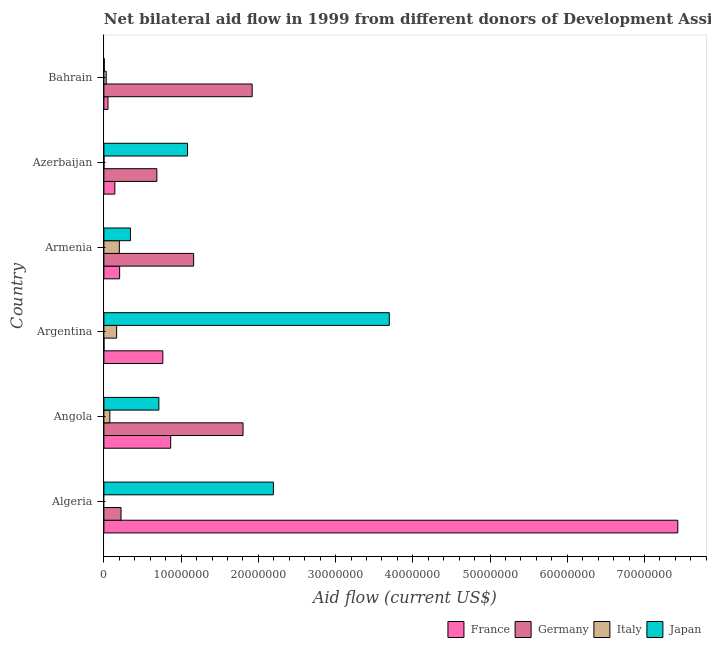How many different coloured bars are there?
Keep it short and to the point. 4. How many groups of bars are there?
Keep it short and to the point. 6. Are the number of bars per tick equal to the number of legend labels?
Offer a very short reply. No. Are the number of bars on each tick of the Y-axis equal?
Ensure brevity in your answer.  No. What is the label of the 2nd group of bars from the top?
Your response must be concise. Azerbaijan. Across all countries, what is the maximum amount of aid given by japan?
Give a very brief answer. 3.70e+07. Across all countries, what is the minimum amount of aid given by japan?
Your response must be concise. 5.00e+04. In which country was the amount of aid given by france maximum?
Your answer should be very brief. Algeria. What is the total amount of aid given by italy in the graph?
Ensure brevity in your answer.  4.73e+06. What is the difference between the amount of aid given by france in Argentina and that in Azerbaijan?
Your answer should be very brief. 6.21e+06. What is the difference between the amount of aid given by italy in Angola and the amount of aid given by germany in Armenia?
Your response must be concise. -1.08e+07. What is the average amount of aid given by germany per country?
Provide a succinct answer. 9.66e+06. What is the difference between the amount of aid given by italy and amount of aid given by japan in Angola?
Offer a very short reply. -6.35e+06. What is the ratio of the amount of aid given by italy in Armenia to that in Bahrain?
Offer a terse response. 6.67. Is the amount of aid given by japan in Algeria less than that in Bahrain?
Your answer should be very brief. No. What is the difference between the highest and the lowest amount of aid given by japan?
Offer a very short reply. 3.69e+07. Is it the case that in every country, the sum of the amount of aid given by italy and amount of aid given by japan is greater than the sum of amount of aid given by germany and amount of aid given by france?
Ensure brevity in your answer.  No. Are all the bars in the graph horizontal?
Offer a very short reply. Yes. How many countries are there in the graph?
Ensure brevity in your answer.  6. Are the values on the major ticks of X-axis written in scientific E-notation?
Your response must be concise. No. Does the graph contain any zero values?
Your response must be concise. Yes. Does the graph contain grids?
Your response must be concise. No. How many legend labels are there?
Keep it short and to the point. 4. What is the title of the graph?
Make the answer very short. Net bilateral aid flow in 1999 from different donors of Development Assistance Committee. Does "Finland" appear as one of the legend labels in the graph?
Your response must be concise. No. What is the Aid flow (current US$) of France in Algeria?
Give a very brief answer. 7.43e+07. What is the Aid flow (current US$) of Germany in Algeria?
Your answer should be very brief. 2.22e+06. What is the Aid flow (current US$) in Italy in Algeria?
Provide a short and direct response. 0. What is the Aid flow (current US$) of Japan in Algeria?
Your answer should be compact. 2.20e+07. What is the Aid flow (current US$) of France in Angola?
Keep it short and to the point. 8.65e+06. What is the Aid flow (current US$) of Germany in Angola?
Provide a succinct answer. 1.80e+07. What is the Aid flow (current US$) of Italy in Angola?
Provide a short and direct response. 7.70e+05. What is the Aid flow (current US$) in Japan in Angola?
Offer a terse response. 7.12e+06. What is the Aid flow (current US$) of France in Argentina?
Offer a terse response. 7.63e+06. What is the Aid flow (current US$) of Germany in Argentina?
Your response must be concise. 10000. What is the Aid flow (current US$) of Italy in Argentina?
Ensure brevity in your answer.  1.65e+06. What is the Aid flow (current US$) in Japan in Argentina?
Make the answer very short. 3.70e+07. What is the Aid flow (current US$) in France in Armenia?
Your answer should be very brief. 2.04e+06. What is the Aid flow (current US$) in Germany in Armenia?
Your response must be concise. 1.16e+07. What is the Aid flow (current US$) in Italy in Armenia?
Keep it short and to the point. 2.00e+06. What is the Aid flow (current US$) of Japan in Armenia?
Give a very brief answer. 3.44e+06. What is the Aid flow (current US$) in France in Azerbaijan?
Provide a short and direct response. 1.42e+06. What is the Aid flow (current US$) of Germany in Azerbaijan?
Make the answer very short. 6.86e+06. What is the Aid flow (current US$) in Italy in Azerbaijan?
Ensure brevity in your answer.  10000. What is the Aid flow (current US$) of Japan in Azerbaijan?
Give a very brief answer. 1.08e+07. What is the Aid flow (current US$) in France in Bahrain?
Keep it short and to the point. 5.30e+05. What is the Aid flow (current US$) in Germany in Bahrain?
Offer a very short reply. 1.92e+07. What is the Aid flow (current US$) of Italy in Bahrain?
Your response must be concise. 3.00e+05. Across all countries, what is the maximum Aid flow (current US$) in France?
Provide a succinct answer. 7.43e+07. Across all countries, what is the maximum Aid flow (current US$) of Germany?
Offer a terse response. 1.92e+07. Across all countries, what is the maximum Aid flow (current US$) in Japan?
Your answer should be compact. 3.70e+07. Across all countries, what is the minimum Aid flow (current US$) of France?
Keep it short and to the point. 5.30e+05. Across all countries, what is the minimum Aid flow (current US$) of Germany?
Your answer should be very brief. 10000. Across all countries, what is the minimum Aid flow (current US$) of Italy?
Provide a short and direct response. 0. Across all countries, what is the minimum Aid flow (current US$) of Japan?
Ensure brevity in your answer.  5.00e+04. What is the total Aid flow (current US$) of France in the graph?
Make the answer very short. 9.46e+07. What is the total Aid flow (current US$) in Germany in the graph?
Ensure brevity in your answer.  5.79e+07. What is the total Aid flow (current US$) of Italy in the graph?
Provide a short and direct response. 4.73e+06. What is the total Aid flow (current US$) in Japan in the graph?
Your answer should be very brief. 8.04e+07. What is the difference between the Aid flow (current US$) in France in Algeria and that in Angola?
Offer a terse response. 6.57e+07. What is the difference between the Aid flow (current US$) in Germany in Algeria and that in Angola?
Offer a terse response. -1.58e+07. What is the difference between the Aid flow (current US$) in Japan in Algeria and that in Angola?
Make the answer very short. 1.48e+07. What is the difference between the Aid flow (current US$) in France in Algeria and that in Argentina?
Give a very brief answer. 6.67e+07. What is the difference between the Aid flow (current US$) in Germany in Algeria and that in Argentina?
Offer a terse response. 2.21e+06. What is the difference between the Aid flow (current US$) of Japan in Algeria and that in Argentina?
Give a very brief answer. -1.50e+07. What is the difference between the Aid flow (current US$) of France in Algeria and that in Armenia?
Give a very brief answer. 7.23e+07. What is the difference between the Aid flow (current US$) of Germany in Algeria and that in Armenia?
Offer a very short reply. -9.40e+06. What is the difference between the Aid flow (current US$) of Japan in Algeria and that in Armenia?
Provide a short and direct response. 1.85e+07. What is the difference between the Aid flow (current US$) of France in Algeria and that in Azerbaijan?
Ensure brevity in your answer.  7.29e+07. What is the difference between the Aid flow (current US$) of Germany in Algeria and that in Azerbaijan?
Ensure brevity in your answer.  -4.64e+06. What is the difference between the Aid flow (current US$) in Japan in Algeria and that in Azerbaijan?
Make the answer very short. 1.11e+07. What is the difference between the Aid flow (current US$) in France in Algeria and that in Bahrain?
Provide a succinct answer. 7.38e+07. What is the difference between the Aid flow (current US$) in Germany in Algeria and that in Bahrain?
Provide a succinct answer. -1.70e+07. What is the difference between the Aid flow (current US$) of Japan in Algeria and that in Bahrain?
Offer a terse response. 2.19e+07. What is the difference between the Aid flow (current US$) of France in Angola and that in Argentina?
Your response must be concise. 1.02e+06. What is the difference between the Aid flow (current US$) of Germany in Angola and that in Argentina?
Your answer should be very brief. 1.80e+07. What is the difference between the Aid flow (current US$) in Italy in Angola and that in Argentina?
Offer a terse response. -8.80e+05. What is the difference between the Aid flow (current US$) in Japan in Angola and that in Argentina?
Provide a short and direct response. -2.98e+07. What is the difference between the Aid flow (current US$) of France in Angola and that in Armenia?
Your answer should be compact. 6.61e+06. What is the difference between the Aid flow (current US$) in Germany in Angola and that in Armenia?
Your response must be concise. 6.40e+06. What is the difference between the Aid flow (current US$) of Italy in Angola and that in Armenia?
Make the answer very short. -1.23e+06. What is the difference between the Aid flow (current US$) in Japan in Angola and that in Armenia?
Ensure brevity in your answer.  3.68e+06. What is the difference between the Aid flow (current US$) in France in Angola and that in Azerbaijan?
Offer a very short reply. 7.23e+06. What is the difference between the Aid flow (current US$) of Germany in Angola and that in Azerbaijan?
Your response must be concise. 1.12e+07. What is the difference between the Aid flow (current US$) of Italy in Angola and that in Azerbaijan?
Ensure brevity in your answer.  7.60e+05. What is the difference between the Aid flow (current US$) of Japan in Angola and that in Azerbaijan?
Offer a very short reply. -3.71e+06. What is the difference between the Aid flow (current US$) in France in Angola and that in Bahrain?
Offer a very short reply. 8.12e+06. What is the difference between the Aid flow (current US$) of Germany in Angola and that in Bahrain?
Offer a very short reply. -1.18e+06. What is the difference between the Aid flow (current US$) of Japan in Angola and that in Bahrain?
Keep it short and to the point. 7.07e+06. What is the difference between the Aid flow (current US$) in France in Argentina and that in Armenia?
Keep it short and to the point. 5.59e+06. What is the difference between the Aid flow (current US$) in Germany in Argentina and that in Armenia?
Offer a terse response. -1.16e+07. What is the difference between the Aid flow (current US$) of Italy in Argentina and that in Armenia?
Make the answer very short. -3.50e+05. What is the difference between the Aid flow (current US$) in Japan in Argentina and that in Armenia?
Your response must be concise. 3.35e+07. What is the difference between the Aid flow (current US$) in France in Argentina and that in Azerbaijan?
Your response must be concise. 6.21e+06. What is the difference between the Aid flow (current US$) of Germany in Argentina and that in Azerbaijan?
Keep it short and to the point. -6.85e+06. What is the difference between the Aid flow (current US$) in Italy in Argentina and that in Azerbaijan?
Provide a short and direct response. 1.64e+06. What is the difference between the Aid flow (current US$) of Japan in Argentina and that in Azerbaijan?
Offer a very short reply. 2.61e+07. What is the difference between the Aid flow (current US$) of France in Argentina and that in Bahrain?
Your response must be concise. 7.10e+06. What is the difference between the Aid flow (current US$) of Germany in Argentina and that in Bahrain?
Offer a terse response. -1.92e+07. What is the difference between the Aid flow (current US$) in Italy in Argentina and that in Bahrain?
Offer a very short reply. 1.35e+06. What is the difference between the Aid flow (current US$) of Japan in Argentina and that in Bahrain?
Make the answer very short. 3.69e+07. What is the difference between the Aid flow (current US$) of France in Armenia and that in Azerbaijan?
Give a very brief answer. 6.20e+05. What is the difference between the Aid flow (current US$) of Germany in Armenia and that in Azerbaijan?
Your response must be concise. 4.76e+06. What is the difference between the Aid flow (current US$) of Italy in Armenia and that in Azerbaijan?
Offer a terse response. 1.99e+06. What is the difference between the Aid flow (current US$) in Japan in Armenia and that in Azerbaijan?
Your answer should be very brief. -7.39e+06. What is the difference between the Aid flow (current US$) of France in Armenia and that in Bahrain?
Your answer should be compact. 1.51e+06. What is the difference between the Aid flow (current US$) in Germany in Armenia and that in Bahrain?
Ensure brevity in your answer.  -7.58e+06. What is the difference between the Aid flow (current US$) in Italy in Armenia and that in Bahrain?
Make the answer very short. 1.70e+06. What is the difference between the Aid flow (current US$) in Japan in Armenia and that in Bahrain?
Your response must be concise. 3.39e+06. What is the difference between the Aid flow (current US$) in France in Azerbaijan and that in Bahrain?
Keep it short and to the point. 8.90e+05. What is the difference between the Aid flow (current US$) of Germany in Azerbaijan and that in Bahrain?
Ensure brevity in your answer.  -1.23e+07. What is the difference between the Aid flow (current US$) of Japan in Azerbaijan and that in Bahrain?
Offer a terse response. 1.08e+07. What is the difference between the Aid flow (current US$) of France in Algeria and the Aid flow (current US$) of Germany in Angola?
Keep it short and to the point. 5.63e+07. What is the difference between the Aid flow (current US$) of France in Algeria and the Aid flow (current US$) of Italy in Angola?
Offer a very short reply. 7.36e+07. What is the difference between the Aid flow (current US$) of France in Algeria and the Aid flow (current US$) of Japan in Angola?
Keep it short and to the point. 6.72e+07. What is the difference between the Aid flow (current US$) in Germany in Algeria and the Aid flow (current US$) in Italy in Angola?
Keep it short and to the point. 1.45e+06. What is the difference between the Aid flow (current US$) in Germany in Algeria and the Aid flow (current US$) in Japan in Angola?
Your answer should be very brief. -4.90e+06. What is the difference between the Aid flow (current US$) in France in Algeria and the Aid flow (current US$) in Germany in Argentina?
Make the answer very short. 7.43e+07. What is the difference between the Aid flow (current US$) in France in Algeria and the Aid flow (current US$) in Italy in Argentina?
Give a very brief answer. 7.27e+07. What is the difference between the Aid flow (current US$) in France in Algeria and the Aid flow (current US$) in Japan in Argentina?
Provide a short and direct response. 3.74e+07. What is the difference between the Aid flow (current US$) of Germany in Algeria and the Aid flow (current US$) of Italy in Argentina?
Provide a succinct answer. 5.70e+05. What is the difference between the Aid flow (current US$) in Germany in Algeria and the Aid flow (current US$) in Japan in Argentina?
Make the answer very short. -3.47e+07. What is the difference between the Aid flow (current US$) in France in Algeria and the Aid flow (current US$) in Germany in Armenia?
Your answer should be compact. 6.27e+07. What is the difference between the Aid flow (current US$) of France in Algeria and the Aid flow (current US$) of Italy in Armenia?
Provide a short and direct response. 7.23e+07. What is the difference between the Aid flow (current US$) of France in Algeria and the Aid flow (current US$) of Japan in Armenia?
Make the answer very short. 7.09e+07. What is the difference between the Aid flow (current US$) of Germany in Algeria and the Aid flow (current US$) of Japan in Armenia?
Your answer should be compact. -1.22e+06. What is the difference between the Aid flow (current US$) of France in Algeria and the Aid flow (current US$) of Germany in Azerbaijan?
Your answer should be compact. 6.75e+07. What is the difference between the Aid flow (current US$) of France in Algeria and the Aid flow (current US$) of Italy in Azerbaijan?
Your response must be concise. 7.43e+07. What is the difference between the Aid flow (current US$) in France in Algeria and the Aid flow (current US$) in Japan in Azerbaijan?
Ensure brevity in your answer.  6.35e+07. What is the difference between the Aid flow (current US$) of Germany in Algeria and the Aid flow (current US$) of Italy in Azerbaijan?
Your answer should be compact. 2.21e+06. What is the difference between the Aid flow (current US$) of Germany in Algeria and the Aid flow (current US$) of Japan in Azerbaijan?
Provide a short and direct response. -8.61e+06. What is the difference between the Aid flow (current US$) of France in Algeria and the Aid flow (current US$) of Germany in Bahrain?
Give a very brief answer. 5.51e+07. What is the difference between the Aid flow (current US$) in France in Algeria and the Aid flow (current US$) in Italy in Bahrain?
Ensure brevity in your answer.  7.40e+07. What is the difference between the Aid flow (current US$) in France in Algeria and the Aid flow (current US$) in Japan in Bahrain?
Give a very brief answer. 7.43e+07. What is the difference between the Aid flow (current US$) of Germany in Algeria and the Aid flow (current US$) of Italy in Bahrain?
Provide a short and direct response. 1.92e+06. What is the difference between the Aid flow (current US$) of Germany in Algeria and the Aid flow (current US$) of Japan in Bahrain?
Offer a terse response. 2.17e+06. What is the difference between the Aid flow (current US$) of France in Angola and the Aid flow (current US$) of Germany in Argentina?
Provide a short and direct response. 8.64e+06. What is the difference between the Aid flow (current US$) of France in Angola and the Aid flow (current US$) of Japan in Argentina?
Ensure brevity in your answer.  -2.83e+07. What is the difference between the Aid flow (current US$) of Germany in Angola and the Aid flow (current US$) of Italy in Argentina?
Ensure brevity in your answer.  1.64e+07. What is the difference between the Aid flow (current US$) in Germany in Angola and the Aid flow (current US$) in Japan in Argentina?
Offer a very short reply. -1.89e+07. What is the difference between the Aid flow (current US$) in Italy in Angola and the Aid flow (current US$) in Japan in Argentina?
Provide a short and direct response. -3.62e+07. What is the difference between the Aid flow (current US$) of France in Angola and the Aid flow (current US$) of Germany in Armenia?
Ensure brevity in your answer.  -2.97e+06. What is the difference between the Aid flow (current US$) in France in Angola and the Aid flow (current US$) in Italy in Armenia?
Make the answer very short. 6.65e+06. What is the difference between the Aid flow (current US$) of France in Angola and the Aid flow (current US$) of Japan in Armenia?
Ensure brevity in your answer.  5.21e+06. What is the difference between the Aid flow (current US$) of Germany in Angola and the Aid flow (current US$) of Italy in Armenia?
Ensure brevity in your answer.  1.60e+07. What is the difference between the Aid flow (current US$) in Germany in Angola and the Aid flow (current US$) in Japan in Armenia?
Offer a very short reply. 1.46e+07. What is the difference between the Aid flow (current US$) of Italy in Angola and the Aid flow (current US$) of Japan in Armenia?
Offer a very short reply. -2.67e+06. What is the difference between the Aid flow (current US$) of France in Angola and the Aid flow (current US$) of Germany in Azerbaijan?
Make the answer very short. 1.79e+06. What is the difference between the Aid flow (current US$) in France in Angola and the Aid flow (current US$) in Italy in Azerbaijan?
Provide a short and direct response. 8.64e+06. What is the difference between the Aid flow (current US$) in France in Angola and the Aid flow (current US$) in Japan in Azerbaijan?
Your response must be concise. -2.18e+06. What is the difference between the Aid flow (current US$) in Germany in Angola and the Aid flow (current US$) in Italy in Azerbaijan?
Provide a succinct answer. 1.80e+07. What is the difference between the Aid flow (current US$) in Germany in Angola and the Aid flow (current US$) in Japan in Azerbaijan?
Provide a short and direct response. 7.19e+06. What is the difference between the Aid flow (current US$) in Italy in Angola and the Aid flow (current US$) in Japan in Azerbaijan?
Make the answer very short. -1.01e+07. What is the difference between the Aid flow (current US$) of France in Angola and the Aid flow (current US$) of Germany in Bahrain?
Keep it short and to the point. -1.06e+07. What is the difference between the Aid flow (current US$) in France in Angola and the Aid flow (current US$) in Italy in Bahrain?
Make the answer very short. 8.35e+06. What is the difference between the Aid flow (current US$) in France in Angola and the Aid flow (current US$) in Japan in Bahrain?
Make the answer very short. 8.60e+06. What is the difference between the Aid flow (current US$) in Germany in Angola and the Aid flow (current US$) in Italy in Bahrain?
Provide a succinct answer. 1.77e+07. What is the difference between the Aid flow (current US$) of Germany in Angola and the Aid flow (current US$) of Japan in Bahrain?
Give a very brief answer. 1.80e+07. What is the difference between the Aid flow (current US$) in Italy in Angola and the Aid flow (current US$) in Japan in Bahrain?
Offer a very short reply. 7.20e+05. What is the difference between the Aid flow (current US$) of France in Argentina and the Aid flow (current US$) of Germany in Armenia?
Offer a terse response. -3.99e+06. What is the difference between the Aid flow (current US$) in France in Argentina and the Aid flow (current US$) in Italy in Armenia?
Give a very brief answer. 5.63e+06. What is the difference between the Aid flow (current US$) of France in Argentina and the Aid flow (current US$) of Japan in Armenia?
Your answer should be compact. 4.19e+06. What is the difference between the Aid flow (current US$) of Germany in Argentina and the Aid flow (current US$) of Italy in Armenia?
Provide a short and direct response. -1.99e+06. What is the difference between the Aid flow (current US$) in Germany in Argentina and the Aid flow (current US$) in Japan in Armenia?
Provide a short and direct response. -3.43e+06. What is the difference between the Aid flow (current US$) in Italy in Argentina and the Aid flow (current US$) in Japan in Armenia?
Give a very brief answer. -1.79e+06. What is the difference between the Aid flow (current US$) of France in Argentina and the Aid flow (current US$) of Germany in Azerbaijan?
Your answer should be very brief. 7.70e+05. What is the difference between the Aid flow (current US$) in France in Argentina and the Aid flow (current US$) in Italy in Azerbaijan?
Make the answer very short. 7.62e+06. What is the difference between the Aid flow (current US$) of France in Argentina and the Aid flow (current US$) of Japan in Azerbaijan?
Give a very brief answer. -3.20e+06. What is the difference between the Aid flow (current US$) in Germany in Argentina and the Aid flow (current US$) in Japan in Azerbaijan?
Offer a very short reply. -1.08e+07. What is the difference between the Aid flow (current US$) in Italy in Argentina and the Aid flow (current US$) in Japan in Azerbaijan?
Offer a very short reply. -9.18e+06. What is the difference between the Aid flow (current US$) of France in Argentina and the Aid flow (current US$) of Germany in Bahrain?
Offer a terse response. -1.16e+07. What is the difference between the Aid flow (current US$) of France in Argentina and the Aid flow (current US$) of Italy in Bahrain?
Give a very brief answer. 7.33e+06. What is the difference between the Aid flow (current US$) of France in Argentina and the Aid flow (current US$) of Japan in Bahrain?
Your response must be concise. 7.58e+06. What is the difference between the Aid flow (current US$) in Germany in Argentina and the Aid flow (current US$) in Italy in Bahrain?
Provide a succinct answer. -2.90e+05. What is the difference between the Aid flow (current US$) in Italy in Argentina and the Aid flow (current US$) in Japan in Bahrain?
Give a very brief answer. 1.60e+06. What is the difference between the Aid flow (current US$) in France in Armenia and the Aid flow (current US$) in Germany in Azerbaijan?
Give a very brief answer. -4.82e+06. What is the difference between the Aid flow (current US$) in France in Armenia and the Aid flow (current US$) in Italy in Azerbaijan?
Your response must be concise. 2.03e+06. What is the difference between the Aid flow (current US$) in France in Armenia and the Aid flow (current US$) in Japan in Azerbaijan?
Offer a very short reply. -8.79e+06. What is the difference between the Aid flow (current US$) of Germany in Armenia and the Aid flow (current US$) of Italy in Azerbaijan?
Offer a very short reply. 1.16e+07. What is the difference between the Aid flow (current US$) in Germany in Armenia and the Aid flow (current US$) in Japan in Azerbaijan?
Ensure brevity in your answer.  7.90e+05. What is the difference between the Aid flow (current US$) in Italy in Armenia and the Aid flow (current US$) in Japan in Azerbaijan?
Ensure brevity in your answer.  -8.83e+06. What is the difference between the Aid flow (current US$) in France in Armenia and the Aid flow (current US$) in Germany in Bahrain?
Your response must be concise. -1.72e+07. What is the difference between the Aid flow (current US$) of France in Armenia and the Aid flow (current US$) of Italy in Bahrain?
Offer a terse response. 1.74e+06. What is the difference between the Aid flow (current US$) in France in Armenia and the Aid flow (current US$) in Japan in Bahrain?
Give a very brief answer. 1.99e+06. What is the difference between the Aid flow (current US$) in Germany in Armenia and the Aid flow (current US$) in Italy in Bahrain?
Provide a succinct answer. 1.13e+07. What is the difference between the Aid flow (current US$) in Germany in Armenia and the Aid flow (current US$) in Japan in Bahrain?
Provide a short and direct response. 1.16e+07. What is the difference between the Aid flow (current US$) of Italy in Armenia and the Aid flow (current US$) of Japan in Bahrain?
Ensure brevity in your answer.  1.95e+06. What is the difference between the Aid flow (current US$) of France in Azerbaijan and the Aid flow (current US$) of Germany in Bahrain?
Provide a short and direct response. -1.78e+07. What is the difference between the Aid flow (current US$) in France in Azerbaijan and the Aid flow (current US$) in Italy in Bahrain?
Provide a short and direct response. 1.12e+06. What is the difference between the Aid flow (current US$) of France in Azerbaijan and the Aid flow (current US$) of Japan in Bahrain?
Offer a terse response. 1.37e+06. What is the difference between the Aid flow (current US$) of Germany in Azerbaijan and the Aid flow (current US$) of Italy in Bahrain?
Offer a terse response. 6.56e+06. What is the difference between the Aid flow (current US$) of Germany in Azerbaijan and the Aid flow (current US$) of Japan in Bahrain?
Keep it short and to the point. 6.81e+06. What is the difference between the Aid flow (current US$) in Italy in Azerbaijan and the Aid flow (current US$) in Japan in Bahrain?
Give a very brief answer. -4.00e+04. What is the average Aid flow (current US$) in France per country?
Your answer should be very brief. 1.58e+07. What is the average Aid flow (current US$) of Germany per country?
Your answer should be compact. 9.66e+06. What is the average Aid flow (current US$) of Italy per country?
Make the answer very short. 7.88e+05. What is the average Aid flow (current US$) in Japan per country?
Give a very brief answer. 1.34e+07. What is the difference between the Aid flow (current US$) of France and Aid flow (current US$) of Germany in Algeria?
Offer a very short reply. 7.21e+07. What is the difference between the Aid flow (current US$) of France and Aid flow (current US$) of Japan in Algeria?
Your answer should be very brief. 5.24e+07. What is the difference between the Aid flow (current US$) of Germany and Aid flow (current US$) of Japan in Algeria?
Keep it short and to the point. -1.97e+07. What is the difference between the Aid flow (current US$) in France and Aid flow (current US$) in Germany in Angola?
Your answer should be compact. -9.37e+06. What is the difference between the Aid flow (current US$) of France and Aid flow (current US$) of Italy in Angola?
Give a very brief answer. 7.88e+06. What is the difference between the Aid flow (current US$) in France and Aid flow (current US$) in Japan in Angola?
Your response must be concise. 1.53e+06. What is the difference between the Aid flow (current US$) in Germany and Aid flow (current US$) in Italy in Angola?
Offer a very short reply. 1.72e+07. What is the difference between the Aid flow (current US$) of Germany and Aid flow (current US$) of Japan in Angola?
Give a very brief answer. 1.09e+07. What is the difference between the Aid flow (current US$) in Italy and Aid flow (current US$) in Japan in Angola?
Make the answer very short. -6.35e+06. What is the difference between the Aid flow (current US$) in France and Aid flow (current US$) in Germany in Argentina?
Keep it short and to the point. 7.62e+06. What is the difference between the Aid flow (current US$) of France and Aid flow (current US$) of Italy in Argentina?
Your answer should be very brief. 5.98e+06. What is the difference between the Aid flow (current US$) in France and Aid flow (current US$) in Japan in Argentina?
Give a very brief answer. -2.93e+07. What is the difference between the Aid flow (current US$) in Germany and Aid flow (current US$) in Italy in Argentina?
Give a very brief answer. -1.64e+06. What is the difference between the Aid flow (current US$) in Germany and Aid flow (current US$) in Japan in Argentina?
Make the answer very short. -3.70e+07. What is the difference between the Aid flow (current US$) of Italy and Aid flow (current US$) of Japan in Argentina?
Your response must be concise. -3.53e+07. What is the difference between the Aid flow (current US$) in France and Aid flow (current US$) in Germany in Armenia?
Give a very brief answer. -9.58e+06. What is the difference between the Aid flow (current US$) of France and Aid flow (current US$) of Italy in Armenia?
Provide a short and direct response. 4.00e+04. What is the difference between the Aid flow (current US$) of France and Aid flow (current US$) of Japan in Armenia?
Ensure brevity in your answer.  -1.40e+06. What is the difference between the Aid flow (current US$) of Germany and Aid flow (current US$) of Italy in Armenia?
Your response must be concise. 9.62e+06. What is the difference between the Aid flow (current US$) in Germany and Aid flow (current US$) in Japan in Armenia?
Your answer should be very brief. 8.18e+06. What is the difference between the Aid flow (current US$) of Italy and Aid flow (current US$) of Japan in Armenia?
Make the answer very short. -1.44e+06. What is the difference between the Aid flow (current US$) of France and Aid flow (current US$) of Germany in Azerbaijan?
Your response must be concise. -5.44e+06. What is the difference between the Aid flow (current US$) in France and Aid flow (current US$) in Italy in Azerbaijan?
Give a very brief answer. 1.41e+06. What is the difference between the Aid flow (current US$) in France and Aid flow (current US$) in Japan in Azerbaijan?
Give a very brief answer. -9.41e+06. What is the difference between the Aid flow (current US$) of Germany and Aid flow (current US$) of Italy in Azerbaijan?
Your answer should be very brief. 6.85e+06. What is the difference between the Aid flow (current US$) of Germany and Aid flow (current US$) of Japan in Azerbaijan?
Keep it short and to the point. -3.97e+06. What is the difference between the Aid flow (current US$) of Italy and Aid flow (current US$) of Japan in Azerbaijan?
Ensure brevity in your answer.  -1.08e+07. What is the difference between the Aid flow (current US$) of France and Aid flow (current US$) of Germany in Bahrain?
Keep it short and to the point. -1.87e+07. What is the difference between the Aid flow (current US$) in France and Aid flow (current US$) in Japan in Bahrain?
Keep it short and to the point. 4.80e+05. What is the difference between the Aid flow (current US$) in Germany and Aid flow (current US$) in Italy in Bahrain?
Keep it short and to the point. 1.89e+07. What is the difference between the Aid flow (current US$) in Germany and Aid flow (current US$) in Japan in Bahrain?
Make the answer very short. 1.92e+07. What is the difference between the Aid flow (current US$) in Italy and Aid flow (current US$) in Japan in Bahrain?
Your answer should be very brief. 2.50e+05. What is the ratio of the Aid flow (current US$) of France in Algeria to that in Angola?
Make the answer very short. 8.59. What is the ratio of the Aid flow (current US$) of Germany in Algeria to that in Angola?
Provide a succinct answer. 0.12. What is the ratio of the Aid flow (current US$) in Japan in Algeria to that in Angola?
Give a very brief answer. 3.08. What is the ratio of the Aid flow (current US$) of France in Algeria to that in Argentina?
Offer a terse response. 9.74. What is the ratio of the Aid flow (current US$) of Germany in Algeria to that in Argentina?
Ensure brevity in your answer.  222. What is the ratio of the Aid flow (current US$) of Japan in Algeria to that in Argentina?
Your response must be concise. 0.59. What is the ratio of the Aid flow (current US$) in France in Algeria to that in Armenia?
Your answer should be very brief. 36.43. What is the ratio of the Aid flow (current US$) of Germany in Algeria to that in Armenia?
Provide a succinct answer. 0.19. What is the ratio of the Aid flow (current US$) of Japan in Algeria to that in Armenia?
Keep it short and to the point. 6.38. What is the ratio of the Aid flow (current US$) of France in Algeria to that in Azerbaijan?
Make the answer very short. 52.34. What is the ratio of the Aid flow (current US$) in Germany in Algeria to that in Azerbaijan?
Provide a succinct answer. 0.32. What is the ratio of the Aid flow (current US$) in Japan in Algeria to that in Azerbaijan?
Offer a very short reply. 2.03. What is the ratio of the Aid flow (current US$) in France in Algeria to that in Bahrain?
Keep it short and to the point. 140.23. What is the ratio of the Aid flow (current US$) in Germany in Algeria to that in Bahrain?
Provide a short and direct response. 0.12. What is the ratio of the Aid flow (current US$) of Japan in Algeria to that in Bahrain?
Provide a succinct answer. 439. What is the ratio of the Aid flow (current US$) in France in Angola to that in Argentina?
Your answer should be very brief. 1.13. What is the ratio of the Aid flow (current US$) of Germany in Angola to that in Argentina?
Ensure brevity in your answer.  1802. What is the ratio of the Aid flow (current US$) of Italy in Angola to that in Argentina?
Keep it short and to the point. 0.47. What is the ratio of the Aid flow (current US$) in Japan in Angola to that in Argentina?
Offer a terse response. 0.19. What is the ratio of the Aid flow (current US$) in France in Angola to that in Armenia?
Offer a terse response. 4.24. What is the ratio of the Aid flow (current US$) in Germany in Angola to that in Armenia?
Make the answer very short. 1.55. What is the ratio of the Aid flow (current US$) of Italy in Angola to that in Armenia?
Your answer should be compact. 0.39. What is the ratio of the Aid flow (current US$) of Japan in Angola to that in Armenia?
Your answer should be compact. 2.07. What is the ratio of the Aid flow (current US$) of France in Angola to that in Azerbaijan?
Offer a terse response. 6.09. What is the ratio of the Aid flow (current US$) of Germany in Angola to that in Azerbaijan?
Your answer should be very brief. 2.63. What is the ratio of the Aid flow (current US$) in Italy in Angola to that in Azerbaijan?
Make the answer very short. 77. What is the ratio of the Aid flow (current US$) in Japan in Angola to that in Azerbaijan?
Your answer should be compact. 0.66. What is the ratio of the Aid flow (current US$) of France in Angola to that in Bahrain?
Keep it short and to the point. 16.32. What is the ratio of the Aid flow (current US$) of Germany in Angola to that in Bahrain?
Offer a terse response. 0.94. What is the ratio of the Aid flow (current US$) of Italy in Angola to that in Bahrain?
Offer a very short reply. 2.57. What is the ratio of the Aid flow (current US$) of Japan in Angola to that in Bahrain?
Provide a short and direct response. 142.4. What is the ratio of the Aid flow (current US$) in France in Argentina to that in Armenia?
Your response must be concise. 3.74. What is the ratio of the Aid flow (current US$) in Germany in Argentina to that in Armenia?
Your answer should be compact. 0. What is the ratio of the Aid flow (current US$) in Italy in Argentina to that in Armenia?
Your answer should be very brief. 0.82. What is the ratio of the Aid flow (current US$) of Japan in Argentina to that in Armenia?
Offer a very short reply. 10.74. What is the ratio of the Aid flow (current US$) of France in Argentina to that in Azerbaijan?
Your answer should be very brief. 5.37. What is the ratio of the Aid flow (current US$) in Germany in Argentina to that in Azerbaijan?
Offer a very short reply. 0. What is the ratio of the Aid flow (current US$) of Italy in Argentina to that in Azerbaijan?
Make the answer very short. 165. What is the ratio of the Aid flow (current US$) in Japan in Argentina to that in Azerbaijan?
Offer a very short reply. 3.41. What is the ratio of the Aid flow (current US$) of France in Argentina to that in Bahrain?
Provide a short and direct response. 14.4. What is the ratio of the Aid flow (current US$) of Germany in Argentina to that in Bahrain?
Offer a terse response. 0. What is the ratio of the Aid flow (current US$) of Japan in Argentina to that in Bahrain?
Provide a succinct answer. 739.2. What is the ratio of the Aid flow (current US$) of France in Armenia to that in Azerbaijan?
Offer a very short reply. 1.44. What is the ratio of the Aid flow (current US$) of Germany in Armenia to that in Azerbaijan?
Offer a terse response. 1.69. What is the ratio of the Aid flow (current US$) of Italy in Armenia to that in Azerbaijan?
Your answer should be very brief. 200. What is the ratio of the Aid flow (current US$) in Japan in Armenia to that in Azerbaijan?
Keep it short and to the point. 0.32. What is the ratio of the Aid flow (current US$) of France in Armenia to that in Bahrain?
Keep it short and to the point. 3.85. What is the ratio of the Aid flow (current US$) of Germany in Armenia to that in Bahrain?
Make the answer very short. 0.61. What is the ratio of the Aid flow (current US$) in Italy in Armenia to that in Bahrain?
Provide a short and direct response. 6.67. What is the ratio of the Aid flow (current US$) of Japan in Armenia to that in Bahrain?
Your answer should be compact. 68.8. What is the ratio of the Aid flow (current US$) in France in Azerbaijan to that in Bahrain?
Your response must be concise. 2.68. What is the ratio of the Aid flow (current US$) in Germany in Azerbaijan to that in Bahrain?
Give a very brief answer. 0.36. What is the ratio of the Aid flow (current US$) in Japan in Azerbaijan to that in Bahrain?
Make the answer very short. 216.6. What is the difference between the highest and the second highest Aid flow (current US$) of France?
Offer a very short reply. 6.57e+07. What is the difference between the highest and the second highest Aid flow (current US$) of Germany?
Keep it short and to the point. 1.18e+06. What is the difference between the highest and the second highest Aid flow (current US$) of Italy?
Offer a very short reply. 3.50e+05. What is the difference between the highest and the second highest Aid flow (current US$) in Japan?
Offer a very short reply. 1.50e+07. What is the difference between the highest and the lowest Aid flow (current US$) of France?
Offer a very short reply. 7.38e+07. What is the difference between the highest and the lowest Aid flow (current US$) of Germany?
Provide a succinct answer. 1.92e+07. What is the difference between the highest and the lowest Aid flow (current US$) in Italy?
Offer a very short reply. 2.00e+06. What is the difference between the highest and the lowest Aid flow (current US$) in Japan?
Your answer should be very brief. 3.69e+07. 